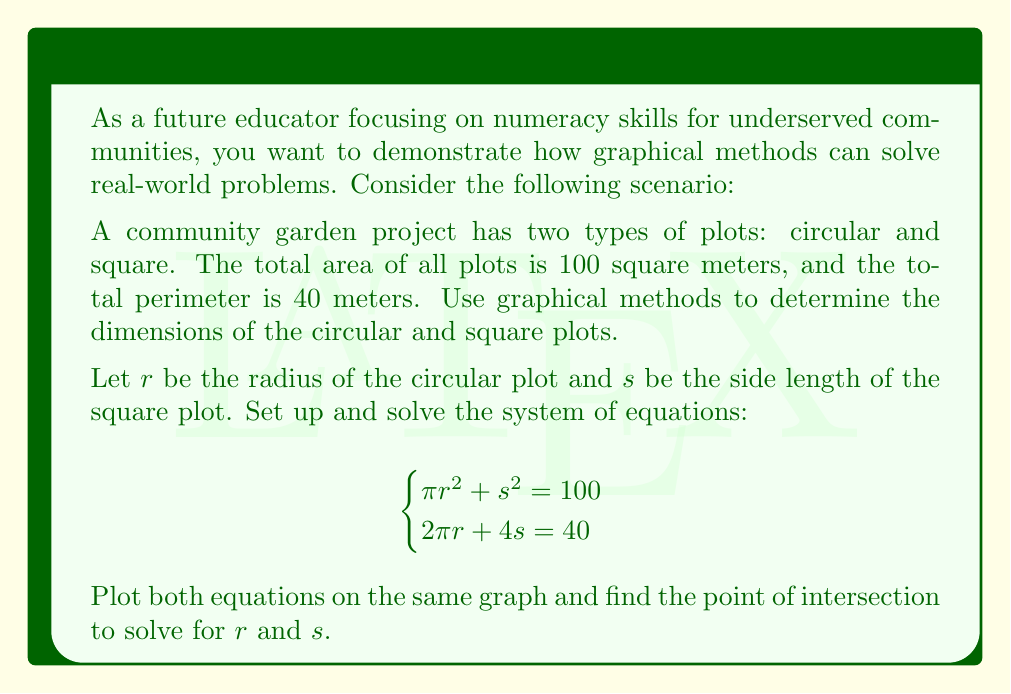Can you answer this question? To solve this system of nonlinear equations graphically, we'll follow these steps:

1) Rearrange the equations to isolate $s$:

   Equation 1: $s = \sqrt{100 - \pi r^2}$
   Equation 2: $s = 10 - \frac{\pi r}{2}$

2) Create a graph with $r$ on the x-axis and $s$ on the y-axis.

3) Plot the first equation:
   - Use values of $r$ from 0 to $\sqrt{\frac{100}{\pi}} \approx 5.64$ (when $s = 0$)
   - Calculate corresponding $s$ values

4) Plot the second equation:
   - This is a straight line
   - When $r = 0$, $s = 10$
   - When $s = 0$, $r = \frac{20}{\pi} \approx 6.37$

5) Find the intersection point of the two curves. This represents the solution.

[asy]
import graph;
size(200);

real f1(real x) {return sqrt(100 - pi*x^2);}
real f2(real x) {return 10 - pi*x/2;}

draw(graph(f1,0,5.64),blue);
draw(graph(f2,0,6.37),red);

dot((3.63,4.3),green);

xaxis("r",0,7,arrow=Arrow);
yaxis("s",0,11,arrow=Arrow);

label("Equation 1",(.5,9),blue);
label("Equation 2",(5,8),red);
label("Solution",(3.63,4.3),SW,green);
[/asy]

6) From the graph, we can estimate the solution:
   $r \approx 3.63$ and $s \approx 4.3$

7) Verify the solution by substituting these values into the original equations:

   $\pi (3.63)^2 + (4.3)^2 \approx 100$
   $2\pi (3.63) + 4(4.3) \approx 40$

This graphical method provides an approximate solution. For a more precise answer, numerical methods would be required.
Answer: $r \approx 3.63$, $s \approx 4.3$ 